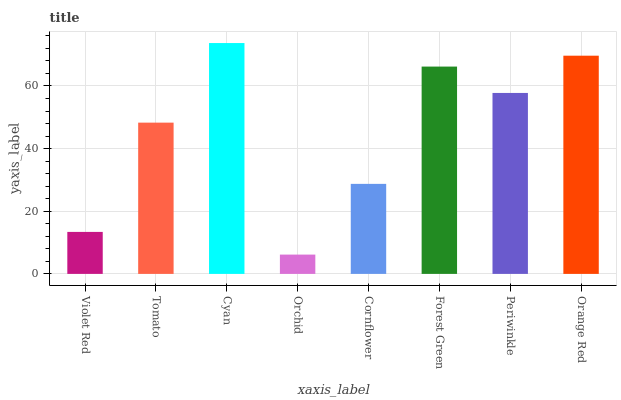Is Orchid the minimum?
Answer yes or no. Yes. Is Cyan the maximum?
Answer yes or no. Yes. Is Tomato the minimum?
Answer yes or no. No. Is Tomato the maximum?
Answer yes or no. No. Is Tomato greater than Violet Red?
Answer yes or no. Yes. Is Violet Red less than Tomato?
Answer yes or no. Yes. Is Violet Red greater than Tomato?
Answer yes or no. No. Is Tomato less than Violet Red?
Answer yes or no. No. Is Periwinkle the high median?
Answer yes or no. Yes. Is Tomato the low median?
Answer yes or no. Yes. Is Cyan the high median?
Answer yes or no. No. Is Orange Red the low median?
Answer yes or no. No. 